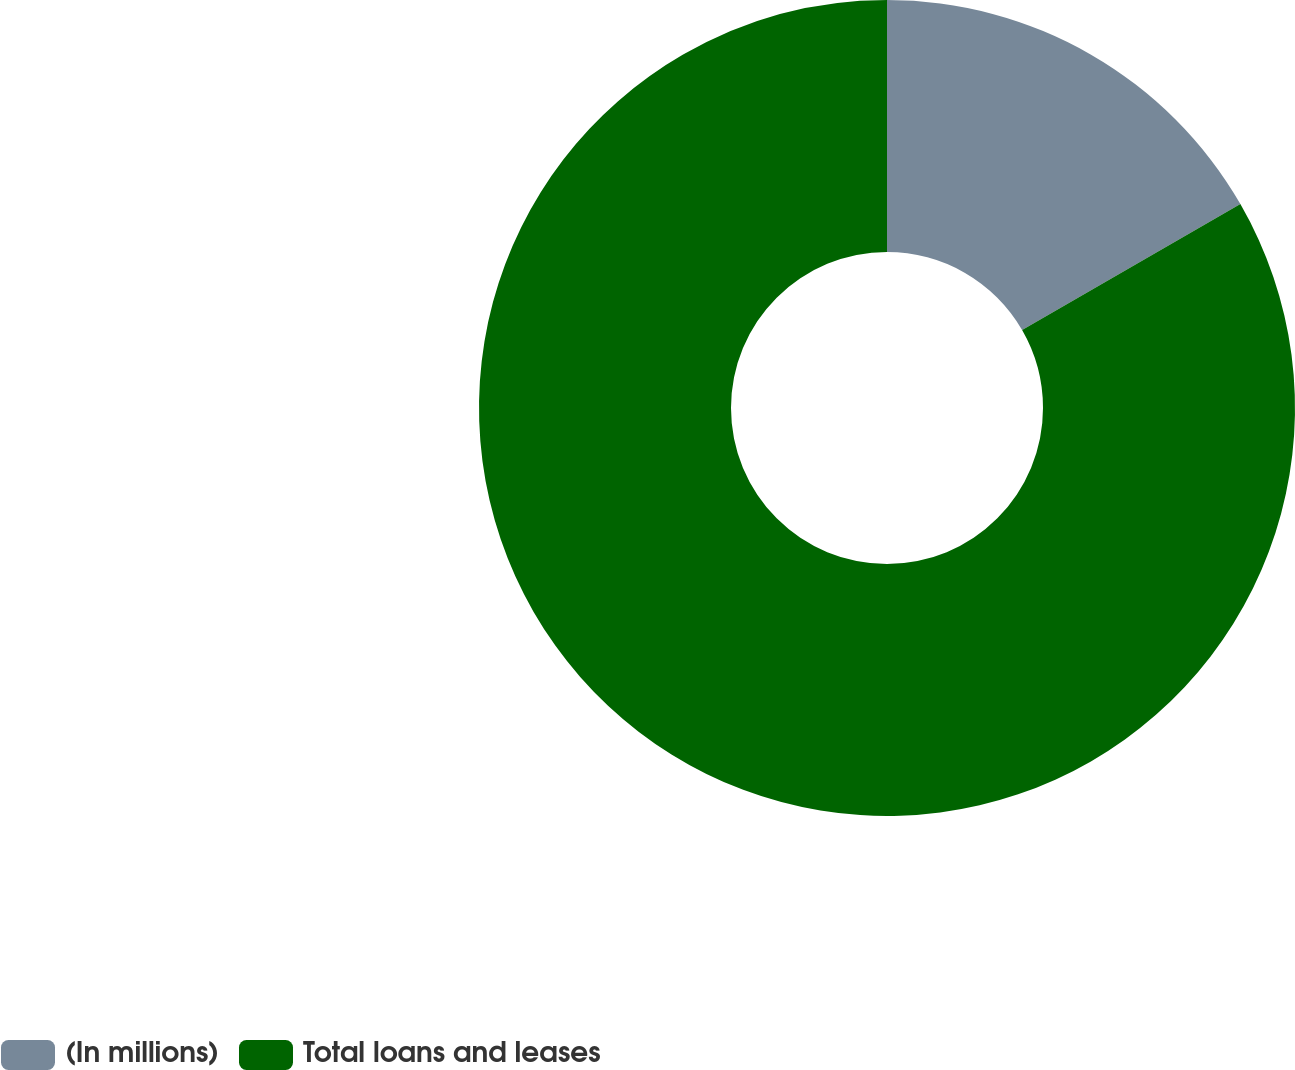<chart> <loc_0><loc_0><loc_500><loc_500><pie_chart><fcel>(In millions)<fcel>Total loans and leases<nl><fcel>16.67%<fcel>83.33%<nl></chart> 